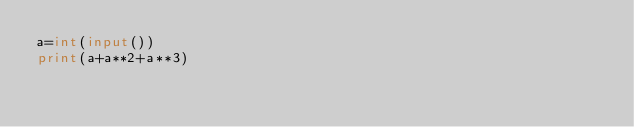<code> <loc_0><loc_0><loc_500><loc_500><_Python_>a=int(input())
print(a+a**2+a**3)</code> 